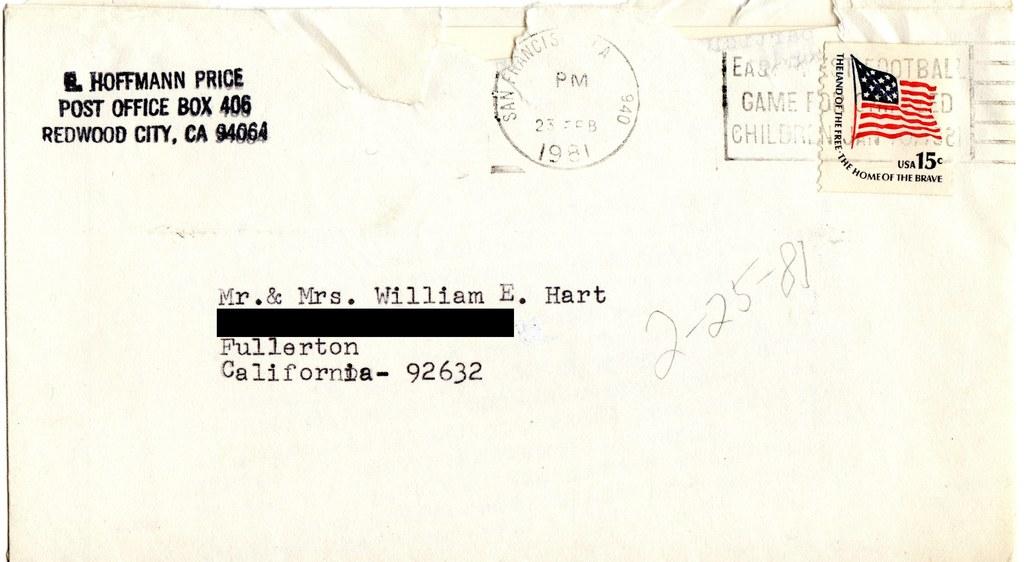Where did this letter come from?
Keep it short and to the point. Redwood city, ca. Who is the letter to?
Provide a succinct answer. Mr. & mrs. william e. hart. 